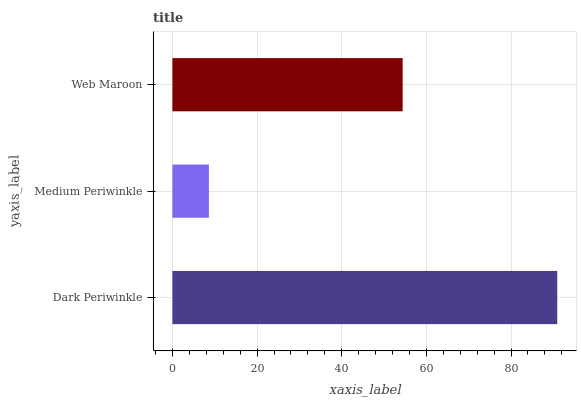Is Medium Periwinkle the minimum?
Answer yes or no. Yes. Is Dark Periwinkle the maximum?
Answer yes or no. Yes. Is Web Maroon the minimum?
Answer yes or no. No. Is Web Maroon the maximum?
Answer yes or no. No. Is Web Maroon greater than Medium Periwinkle?
Answer yes or no. Yes. Is Medium Periwinkle less than Web Maroon?
Answer yes or no. Yes. Is Medium Periwinkle greater than Web Maroon?
Answer yes or no. No. Is Web Maroon less than Medium Periwinkle?
Answer yes or no. No. Is Web Maroon the high median?
Answer yes or no. Yes. Is Web Maroon the low median?
Answer yes or no. Yes. Is Medium Periwinkle the high median?
Answer yes or no. No. Is Medium Periwinkle the low median?
Answer yes or no. No. 